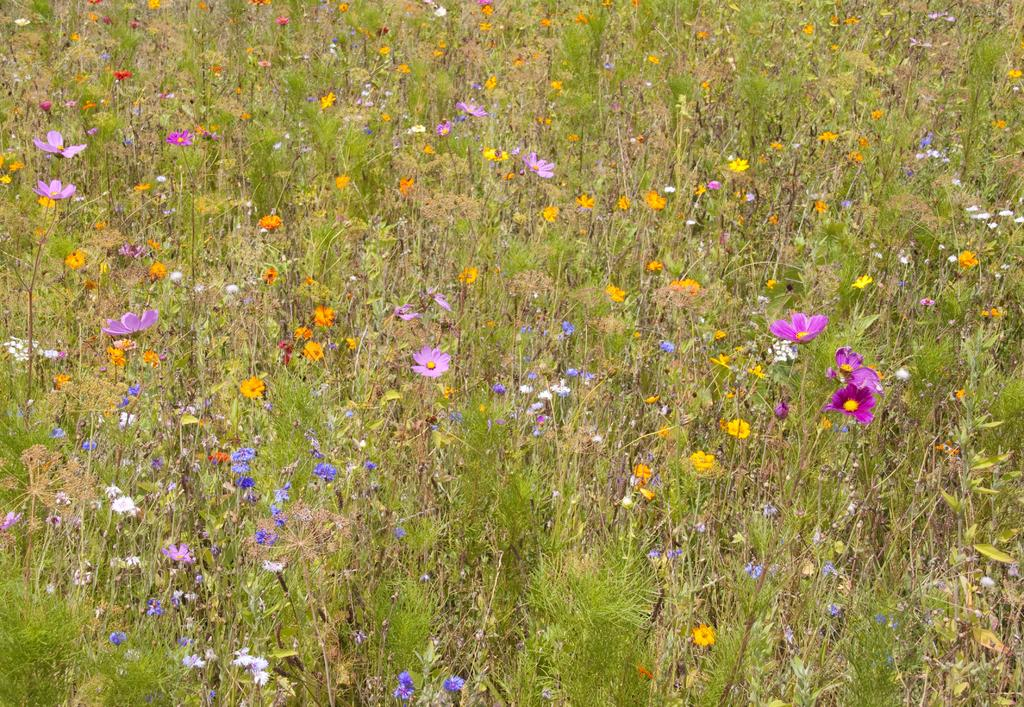What type of living organisms can be seen in the image? Plants and flowers can be seen in the image. Can you describe the flowers in the image? Yes, there are flowers in the image. What type of pen can be seen in the image? There is no pen present in the image. What type of air is visible in the image? There is no specific type of air visible in the image; air is not a visible substance. 